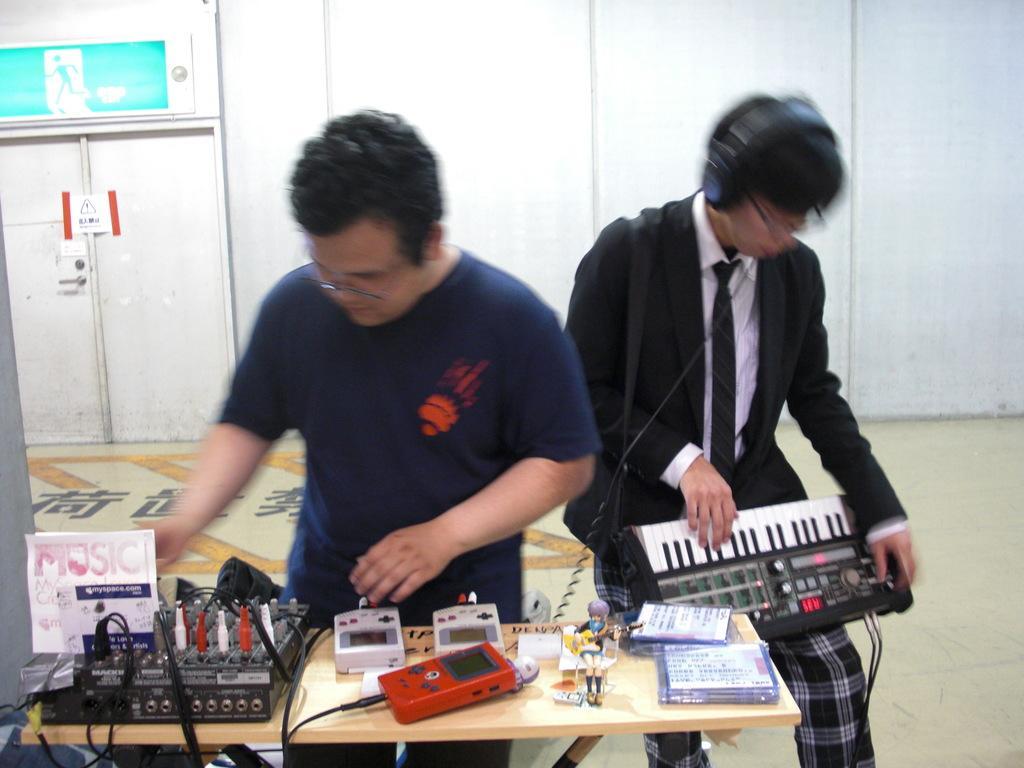Please provide a concise description of this image. In the image we can see there are two people who are standing and playing musical instruments and another man is checking the switches of the circuit. 